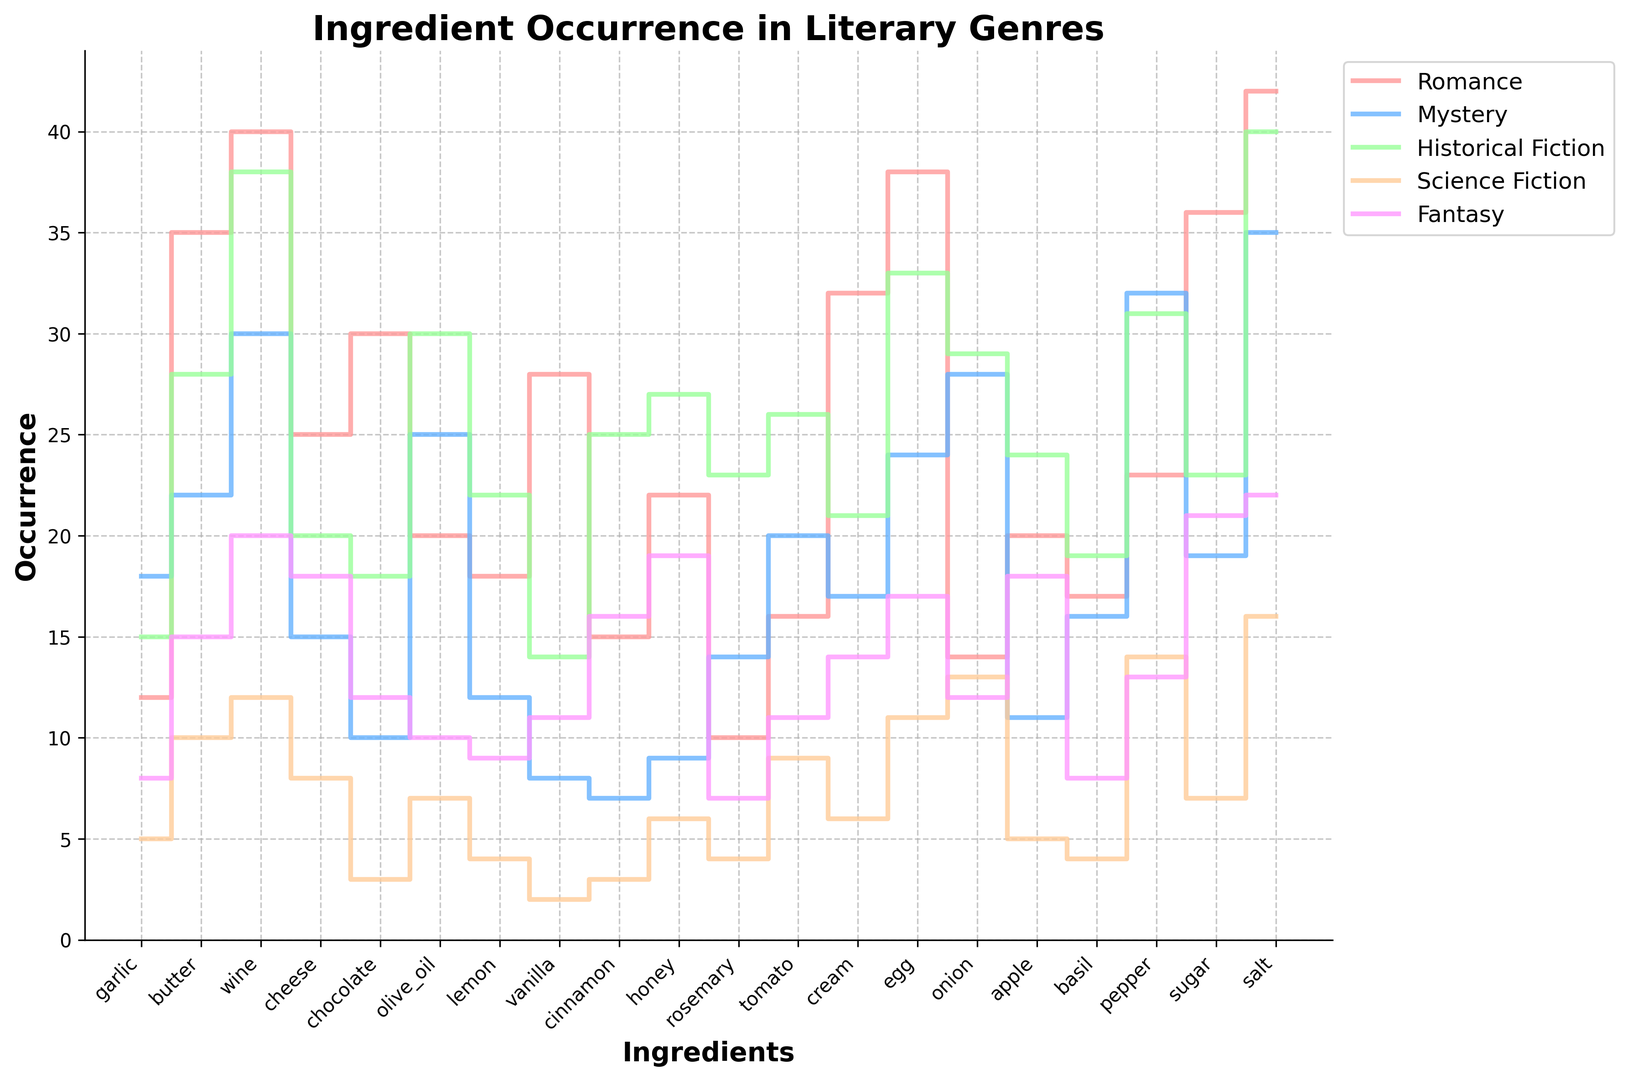What is the most popular ingredient in romance novels? Look at the height of the steps for the "Romance" line (red). The highest step indicates the most popular ingredient. The maximum value is 42 for salt.
Answer: salt Which genre mentions wine more frequently, fantasy or science fiction? Compare the step heights of wine in the "Fantasy" (purple) and "Science Fiction" (orange) lines. Fantasy has a step height of 20, while Science Fiction has a step height of 12.
Answer: fantasy What is the average occurrence of garlic across all genres? Calculate the average by summing the occurrences of garlic in all genres (12 + 18 + 15 + 5 + 8) and dividing by the number of genres (5). The sum is 58, and the average is 58 / 5 = 11.6.
Answer: 11.6 Which two ingredients have the closest number of mentions in the historical fiction genre? Observe the step heights for the "Historical Fiction" line (green). Cinnamon (25) and Apple (24) are the closest with a difference of 1.
Answer: cinnamon and apple Which ingredient is mentioned the least in science fiction? Look at the lowest step height in the "Science Fiction" line (orange). Vanilla and cinnamon each have a step height of 2, which is the lowest.
Answer: vanilla and cinnamon Which genre has the highest occurrence for olive oil? Compare the step heights for olive oil across all genres. The "Historical Fiction" line (green) has the highest step height for olive oil at 30.
Answer: historical fiction For the ingredient pepper, which genre has the highest occurrence and what is the value? Analyze the step heights for pepper. The "Mystery" (blue) line has the highest step height at 32.
Answer: mystery, 32 What is the difference in the number of mentions of cheese between romance and mystery genres? Look at the step heights for cheese in "Romance" (25) and "Mystery" (15) lines. The difference is 25 - 15 = 10.
Answer: 10 How many more mentions does chocolate have in the romance genre compared to mystery? Observe the step heights for chocolate in "Romance" (30) and "Mystery" (10) lines. The difference is 30 - 10 = 20.
Answer: 20 Which ingredient has almost equal occurrences in fantasy and historical fiction genres? Compare the step heights for each ingredient between "Fantasy" and "Historical Fiction" lines. Egg has 17 in "Fantasy" and 33 in "Historical Fiction," so it's closest, but a better match is honey with 19 in "Fantasy" and 27 in "Historical Fiction." This shows they are not very close but the closest available in our dataset.
Answer: honey 